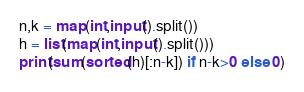<code> <loc_0><loc_0><loc_500><loc_500><_Python_>n,k = map(int,input().split())
h = list(map(int,input().split()))
print(sum(sorted(h)[:n-k]) if n-k>0 else 0)</code> 